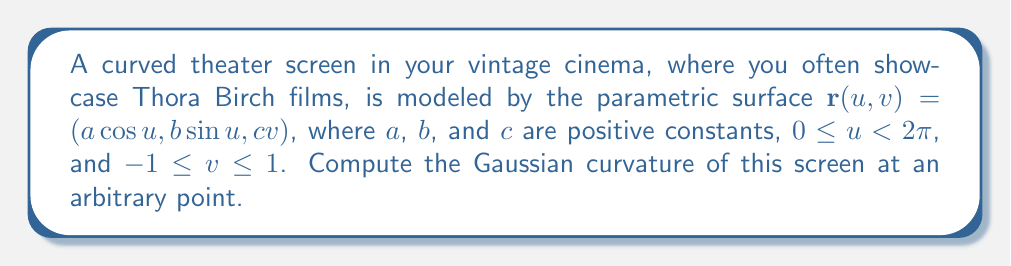Help me with this question. To compute the Gaussian curvature, we'll follow these steps:

1) First, we need to calculate the coefficients of the first fundamental form:
   $E = \mathbf{r}_u \cdot \mathbf{r}_u$, $F = \mathbf{r}_u \cdot \mathbf{r}_v$, $G = \mathbf{r}_v \cdot \mathbf{r}_v$

   $\mathbf{r}_u = (-a\sin u, b\cos u, 0)$
   $\mathbf{r}_v = (0, 0, c)$

   $E = a^2\sin^2 u + b^2\cos^2 u$
   $F = 0$
   $G = c^2$

2) Next, we calculate the coefficients of the second fundamental form:
   $e = \mathbf{n} \cdot \mathbf{r}_{uu}$, $f = \mathbf{n} \cdot \mathbf{r}_{uv}$, $g = \mathbf{n} \cdot \mathbf{r}_{vv}$

   $\mathbf{r}_{uu} = (-a\cos u, -b\sin u, 0)$
   $\mathbf{r}_{uv} = \mathbf{r}_{vu} = (0, 0, 0)$
   $\mathbf{r}_{vv} = (0, 0, 0)$

   The unit normal vector $\mathbf{n}$ is:
   $\mathbf{n} = \frac{\mathbf{r}_u \times \mathbf{r}_v}{|\mathbf{r}_u \times \mathbf{r}_v|} = \frac{(bc\cos u, ac\sin u, ab)}{c\sqrt{a^2\sin^2 u + b^2\cos^2 u}}$

   Now we can calculate $e$, $f$, and $g$:
   $e = \frac{-abc}{\sqrt{a^2\sin^2 u + b^2\cos^2 u}}$
   $f = 0$
   $g = 0$

3) The Gaussian curvature $K$ is given by:
   $$K = \frac{eg - f^2}{EG - F^2}$$

4) Substituting our calculated values:
   $$K = \frac{(-abc/\sqrt{a^2\sin^2 u + b^2\cos^2 u})(0) - (0)^2}{(a^2\sin^2 u + b^2\cos^2 u)(c^2) - (0)^2}$$

5) Simplifying:
   $$K = \frac{0}{c^2(a^2\sin^2 u + b^2\cos^2 u)} = 0$$

Therefore, the Gaussian curvature is zero at all points on the screen.
Answer: $K = 0$ 